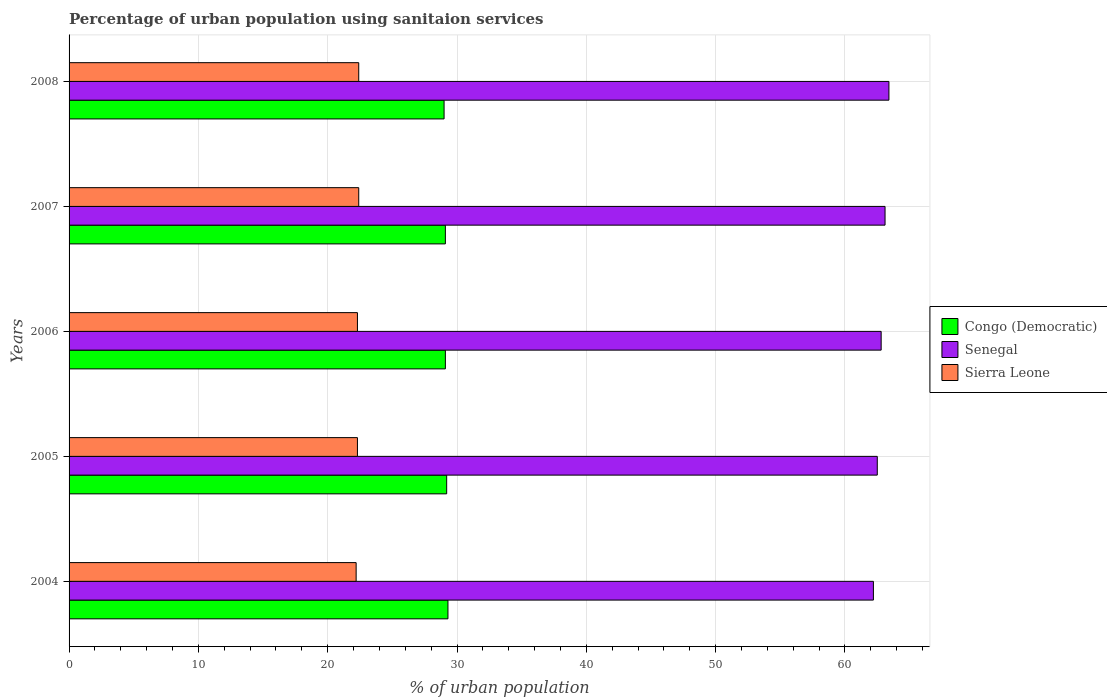Are the number of bars per tick equal to the number of legend labels?
Keep it short and to the point. Yes. Are the number of bars on each tick of the Y-axis equal?
Provide a short and direct response. Yes. How many bars are there on the 5th tick from the top?
Your answer should be compact. 3. How many bars are there on the 3rd tick from the bottom?
Your answer should be very brief. 3. In how many cases, is the number of bars for a given year not equal to the number of legend labels?
Provide a succinct answer. 0. What is the percentage of urban population using sanitaion services in Sierra Leone in 2005?
Provide a succinct answer. 22.3. Across all years, what is the maximum percentage of urban population using sanitaion services in Sierra Leone?
Offer a terse response. 22.4. Across all years, what is the minimum percentage of urban population using sanitaion services in Sierra Leone?
Your answer should be compact. 22.2. What is the total percentage of urban population using sanitaion services in Senegal in the graph?
Keep it short and to the point. 314. What is the difference between the percentage of urban population using sanitaion services in Congo (Democratic) in 2004 and that in 2008?
Your response must be concise. 0.3. What is the difference between the percentage of urban population using sanitaion services in Congo (Democratic) in 2005 and the percentage of urban population using sanitaion services in Sierra Leone in 2008?
Make the answer very short. 6.8. What is the average percentage of urban population using sanitaion services in Sierra Leone per year?
Ensure brevity in your answer.  22.32. In the year 2006, what is the difference between the percentage of urban population using sanitaion services in Senegal and percentage of urban population using sanitaion services in Sierra Leone?
Ensure brevity in your answer.  40.5. In how many years, is the percentage of urban population using sanitaion services in Congo (Democratic) greater than 8 %?
Give a very brief answer. 5. What is the ratio of the percentage of urban population using sanitaion services in Congo (Democratic) in 2004 to that in 2007?
Offer a terse response. 1.01. Is the percentage of urban population using sanitaion services in Sierra Leone in 2005 less than that in 2006?
Keep it short and to the point. No. What is the difference between the highest and the second highest percentage of urban population using sanitaion services in Sierra Leone?
Give a very brief answer. 0. What is the difference between the highest and the lowest percentage of urban population using sanitaion services in Congo (Democratic)?
Give a very brief answer. 0.3. In how many years, is the percentage of urban population using sanitaion services in Congo (Democratic) greater than the average percentage of urban population using sanitaion services in Congo (Democratic) taken over all years?
Offer a very short reply. 2. Is the sum of the percentage of urban population using sanitaion services in Congo (Democratic) in 2006 and 2007 greater than the maximum percentage of urban population using sanitaion services in Sierra Leone across all years?
Make the answer very short. Yes. What does the 2nd bar from the top in 2004 represents?
Your answer should be very brief. Senegal. What does the 2nd bar from the bottom in 2007 represents?
Keep it short and to the point. Senegal. Is it the case that in every year, the sum of the percentage of urban population using sanitaion services in Senegal and percentage of urban population using sanitaion services in Sierra Leone is greater than the percentage of urban population using sanitaion services in Congo (Democratic)?
Ensure brevity in your answer.  Yes. Are all the bars in the graph horizontal?
Keep it short and to the point. Yes. Are the values on the major ticks of X-axis written in scientific E-notation?
Make the answer very short. No. Does the graph contain any zero values?
Your answer should be compact. No. Where does the legend appear in the graph?
Offer a terse response. Center right. What is the title of the graph?
Keep it short and to the point. Percentage of urban population using sanitaion services. What is the label or title of the X-axis?
Keep it short and to the point. % of urban population. What is the label or title of the Y-axis?
Provide a succinct answer. Years. What is the % of urban population of Congo (Democratic) in 2004?
Keep it short and to the point. 29.3. What is the % of urban population of Senegal in 2004?
Your response must be concise. 62.2. What is the % of urban population in Sierra Leone in 2004?
Ensure brevity in your answer.  22.2. What is the % of urban population of Congo (Democratic) in 2005?
Keep it short and to the point. 29.2. What is the % of urban population in Senegal in 2005?
Give a very brief answer. 62.5. What is the % of urban population in Sierra Leone in 2005?
Your answer should be compact. 22.3. What is the % of urban population in Congo (Democratic) in 2006?
Provide a succinct answer. 29.1. What is the % of urban population in Senegal in 2006?
Make the answer very short. 62.8. What is the % of urban population of Sierra Leone in 2006?
Offer a terse response. 22.3. What is the % of urban population in Congo (Democratic) in 2007?
Your answer should be very brief. 29.1. What is the % of urban population of Senegal in 2007?
Provide a short and direct response. 63.1. What is the % of urban population of Sierra Leone in 2007?
Make the answer very short. 22.4. What is the % of urban population of Congo (Democratic) in 2008?
Your answer should be very brief. 29. What is the % of urban population of Senegal in 2008?
Ensure brevity in your answer.  63.4. What is the % of urban population of Sierra Leone in 2008?
Make the answer very short. 22.4. Across all years, what is the maximum % of urban population of Congo (Democratic)?
Offer a terse response. 29.3. Across all years, what is the maximum % of urban population in Senegal?
Keep it short and to the point. 63.4. Across all years, what is the maximum % of urban population in Sierra Leone?
Ensure brevity in your answer.  22.4. Across all years, what is the minimum % of urban population in Senegal?
Make the answer very short. 62.2. What is the total % of urban population of Congo (Democratic) in the graph?
Provide a succinct answer. 145.7. What is the total % of urban population in Senegal in the graph?
Your answer should be compact. 314. What is the total % of urban population of Sierra Leone in the graph?
Your answer should be compact. 111.6. What is the difference between the % of urban population in Congo (Democratic) in 2004 and that in 2005?
Provide a short and direct response. 0.1. What is the difference between the % of urban population of Senegal in 2004 and that in 2005?
Provide a succinct answer. -0.3. What is the difference between the % of urban population of Sierra Leone in 2004 and that in 2006?
Offer a very short reply. -0.1. What is the difference between the % of urban population in Congo (Democratic) in 2004 and that in 2007?
Provide a short and direct response. 0.2. What is the difference between the % of urban population in Senegal in 2004 and that in 2007?
Ensure brevity in your answer.  -0.9. What is the difference between the % of urban population of Sierra Leone in 2004 and that in 2007?
Provide a short and direct response. -0.2. What is the difference between the % of urban population in Congo (Democratic) in 2004 and that in 2008?
Your answer should be compact. 0.3. What is the difference between the % of urban population of Congo (Democratic) in 2005 and that in 2006?
Provide a short and direct response. 0.1. What is the difference between the % of urban population of Sierra Leone in 2005 and that in 2006?
Your response must be concise. 0. What is the difference between the % of urban population in Congo (Democratic) in 2005 and that in 2007?
Ensure brevity in your answer.  0.1. What is the difference between the % of urban population of Senegal in 2005 and that in 2007?
Your response must be concise. -0.6. What is the difference between the % of urban population in Sierra Leone in 2005 and that in 2007?
Keep it short and to the point. -0.1. What is the difference between the % of urban population in Senegal in 2005 and that in 2008?
Provide a short and direct response. -0.9. What is the difference between the % of urban population in Congo (Democratic) in 2006 and that in 2008?
Ensure brevity in your answer.  0.1. What is the difference between the % of urban population in Sierra Leone in 2006 and that in 2008?
Offer a terse response. -0.1. What is the difference between the % of urban population in Congo (Democratic) in 2007 and that in 2008?
Provide a succinct answer. 0.1. What is the difference between the % of urban population in Senegal in 2007 and that in 2008?
Your answer should be compact. -0.3. What is the difference between the % of urban population of Congo (Democratic) in 2004 and the % of urban population of Senegal in 2005?
Your answer should be compact. -33.2. What is the difference between the % of urban population of Congo (Democratic) in 2004 and the % of urban population of Sierra Leone in 2005?
Your answer should be very brief. 7. What is the difference between the % of urban population of Senegal in 2004 and the % of urban population of Sierra Leone in 2005?
Keep it short and to the point. 39.9. What is the difference between the % of urban population in Congo (Democratic) in 2004 and the % of urban population in Senegal in 2006?
Keep it short and to the point. -33.5. What is the difference between the % of urban population in Congo (Democratic) in 2004 and the % of urban population in Sierra Leone in 2006?
Make the answer very short. 7. What is the difference between the % of urban population of Senegal in 2004 and the % of urban population of Sierra Leone in 2006?
Your response must be concise. 39.9. What is the difference between the % of urban population in Congo (Democratic) in 2004 and the % of urban population in Senegal in 2007?
Offer a terse response. -33.8. What is the difference between the % of urban population in Congo (Democratic) in 2004 and the % of urban population in Sierra Leone in 2007?
Offer a terse response. 6.9. What is the difference between the % of urban population of Senegal in 2004 and the % of urban population of Sierra Leone in 2007?
Provide a short and direct response. 39.8. What is the difference between the % of urban population of Congo (Democratic) in 2004 and the % of urban population of Senegal in 2008?
Offer a terse response. -34.1. What is the difference between the % of urban population of Congo (Democratic) in 2004 and the % of urban population of Sierra Leone in 2008?
Offer a terse response. 6.9. What is the difference between the % of urban population of Senegal in 2004 and the % of urban population of Sierra Leone in 2008?
Your response must be concise. 39.8. What is the difference between the % of urban population in Congo (Democratic) in 2005 and the % of urban population in Senegal in 2006?
Provide a succinct answer. -33.6. What is the difference between the % of urban population of Congo (Democratic) in 2005 and the % of urban population of Sierra Leone in 2006?
Ensure brevity in your answer.  6.9. What is the difference between the % of urban population of Senegal in 2005 and the % of urban population of Sierra Leone in 2006?
Your answer should be compact. 40.2. What is the difference between the % of urban population of Congo (Democratic) in 2005 and the % of urban population of Senegal in 2007?
Offer a terse response. -33.9. What is the difference between the % of urban population of Senegal in 2005 and the % of urban population of Sierra Leone in 2007?
Make the answer very short. 40.1. What is the difference between the % of urban population in Congo (Democratic) in 2005 and the % of urban population in Senegal in 2008?
Provide a short and direct response. -34.2. What is the difference between the % of urban population of Senegal in 2005 and the % of urban population of Sierra Leone in 2008?
Ensure brevity in your answer.  40.1. What is the difference between the % of urban population in Congo (Democratic) in 2006 and the % of urban population in Senegal in 2007?
Make the answer very short. -34. What is the difference between the % of urban population of Congo (Democratic) in 2006 and the % of urban population of Sierra Leone in 2007?
Your answer should be very brief. 6.7. What is the difference between the % of urban population of Senegal in 2006 and the % of urban population of Sierra Leone in 2007?
Keep it short and to the point. 40.4. What is the difference between the % of urban population in Congo (Democratic) in 2006 and the % of urban population in Senegal in 2008?
Keep it short and to the point. -34.3. What is the difference between the % of urban population of Congo (Democratic) in 2006 and the % of urban population of Sierra Leone in 2008?
Offer a very short reply. 6.7. What is the difference between the % of urban population of Senegal in 2006 and the % of urban population of Sierra Leone in 2008?
Ensure brevity in your answer.  40.4. What is the difference between the % of urban population of Congo (Democratic) in 2007 and the % of urban population of Senegal in 2008?
Your answer should be very brief. -34.3. What is the difference between the % of urban population in Congo (Democratic) in 2007 and the % of urban population in Sierra Leone in 2008?
Your answer should be very brief. 6.7. What is the difference between the % of urban population in Senegal in 2007 and the % of urban population in Sierra Leone in 2008?
Provide a short and direct response. 40.7. What is the average % of urban population in Congo (Democratic) per year?
Your answer should be compact. 29.14. What is the average % of urban population of Senegal per year?
Offer a very short reply. 62.8. What is the average % of urban population of Sierra Leone per year?
Make the answer very short. 22.32. In the year 2004, what is the difference between the % of urban population of Congo (Democratic) and % of urban population of Senegal?
Ensure brevity in your answer.  -32.9. In the year 2005, what is the difference between the % of urban population of Congo (Democratic) and % of urban population of Senegal?
Ensure brevity in your answer.  -33.3. In the year 2005, what is the difference between the % of urban population of Congo (Democratic) and % of urban population of Sierra Leone?
Keep it short and to the point. 6.9. In the year 2005, what is the difference between the % of urban population in Senegal and % of urban population in Sierra Leone?
Offer a terse response. 40.2. In the year 2006, what is the difference between the % of urban population of Congo (Democratic) and % of urban population of Senegal?
Keep it short and to the point. -33.7. In the year 2006, what is the difference between the % of urban population in Senegal and % of urban population in Sierra Leone?
Your response must be concise. 40.5. In the year 2007, what is the difference between the % of urban population of Congo (Democratic) and % of urban population of Senegal?
Make the answer very short. -34. In the year 2007, what is the difference between the % of urban population of Congo (Democratic) and % of urban population of Sierra Leone?
Offer a very short reply. 6.7. In the year 2007, what is the difference between the % of urban population in Senegal and % of urban population in Sierra Leone?
Your response must be concise. 40.7. In the year 2008, what is the difference between the % of urban population in Congo (Democratic) and % of urban population in Senegal?
Ensure brevity in your answer.  -34.4. In the year 2008, what is the difference between the % of urban population in Senegal and % of urban population in Sierra Leone?
Give a very brief answer. 41. What is the ratio of the % of urban population of Congo (Democratic) in 2004 to that in 2005?
Your answer should be very brief. 1. What is the ratio of the % of urban population in Senegal in 2004 to that in 2005?
Give a very brief answer. 1. What is the ratio of the % of urban population in Sierra Leone in 2004 to that in 2005?
Provide a short and direct response. 1. What is the ratio of the % of urban population of Senegal in 2004 to that in 2006?
Keep it short and to the point. 0.99. What is the ratio of the % of urban population of Sierra Leone in 2004 to that in 2006?
Provide a succinct answer. 1. What is the ratio of the % of urban population of Senegal in 2004 to that in 2007?
Offer a very short reply. 0.99. What is the ratio of the % of urban population in Sierra Leone in 2004 to that in 2007?
Offer a very short reply. 0.99. What is the ratio of the % of urban population of Congo (Democratic) in 2004 to that in 2008?
Provide a succinct answer. 1.01. What is the ratio of the % of urban population in Senegal in 2004 to that in 2008?
Provide a succinct answer. 0.98. What is the ratio of the % of urban population in Congo (Democratic) in 2005 to that in 2006?
Offer a terse response. 1. What is the ratio of the % of urban population in Congo (Democratic) in 2005 to that in 2007?
Give a very brief answer. 1. What is the ratio of the % of urban population in Senegal in 2005 to that in 2007?
Your response must be concise. 0.99. What is the ratio of the % of urban population in Sierra Leone in 2005 to that in 2007?
Your answer should be compact. 1. What is the ratio of the % of urban population in Congo (Democratic) in 2005 to that in 2008?
Your answer should be compact. 1.01. What is the ratio of the % of urban population in Senegal in 2005 to that in 2008?
Make the answer very short. 0.99. What is the ratio of the % of urban population in Congo (Democratic) in 2006 to that in 2007?
Ensure brevity in your answer.  1. What is the ratio of the % of urban population of Congo (Democratic) in 2006 to that in 2008?
Ensure brevity in your answer.  1. What is the ratio of the % of urban population of Senegal in 2006 to that in 2008?
Provide a succinct answer. 0.99. What is the ratio of the % of urban population in Congo (Democratic) in 2007 to that in 2008?
Your response must be concise. 1. What is the ratio of the % of urban population of Senegal in 2007 to that in 2008?
Give a very brief answer. 1. What is the difference between the highest and the second highest % of urban population in Congo (Democratic)?
Your answer should be very brief. 0.1. What is the difference between the highest and the second highest % of urban population of Senegal?
Give a very brief answer. 0.3. What is the difference between the highest and the second highest % of urban population in Sierra Leone?
Your answer should be very brief. 0. What is the difference between the highest and the lowest % of urban population in Congo (Democratic)?
Give a very brief answer. 0.3. What is the difference between the highest and the lowest % of urban population in Sierra Leone?
Provide a short and direct response. 0.2. 